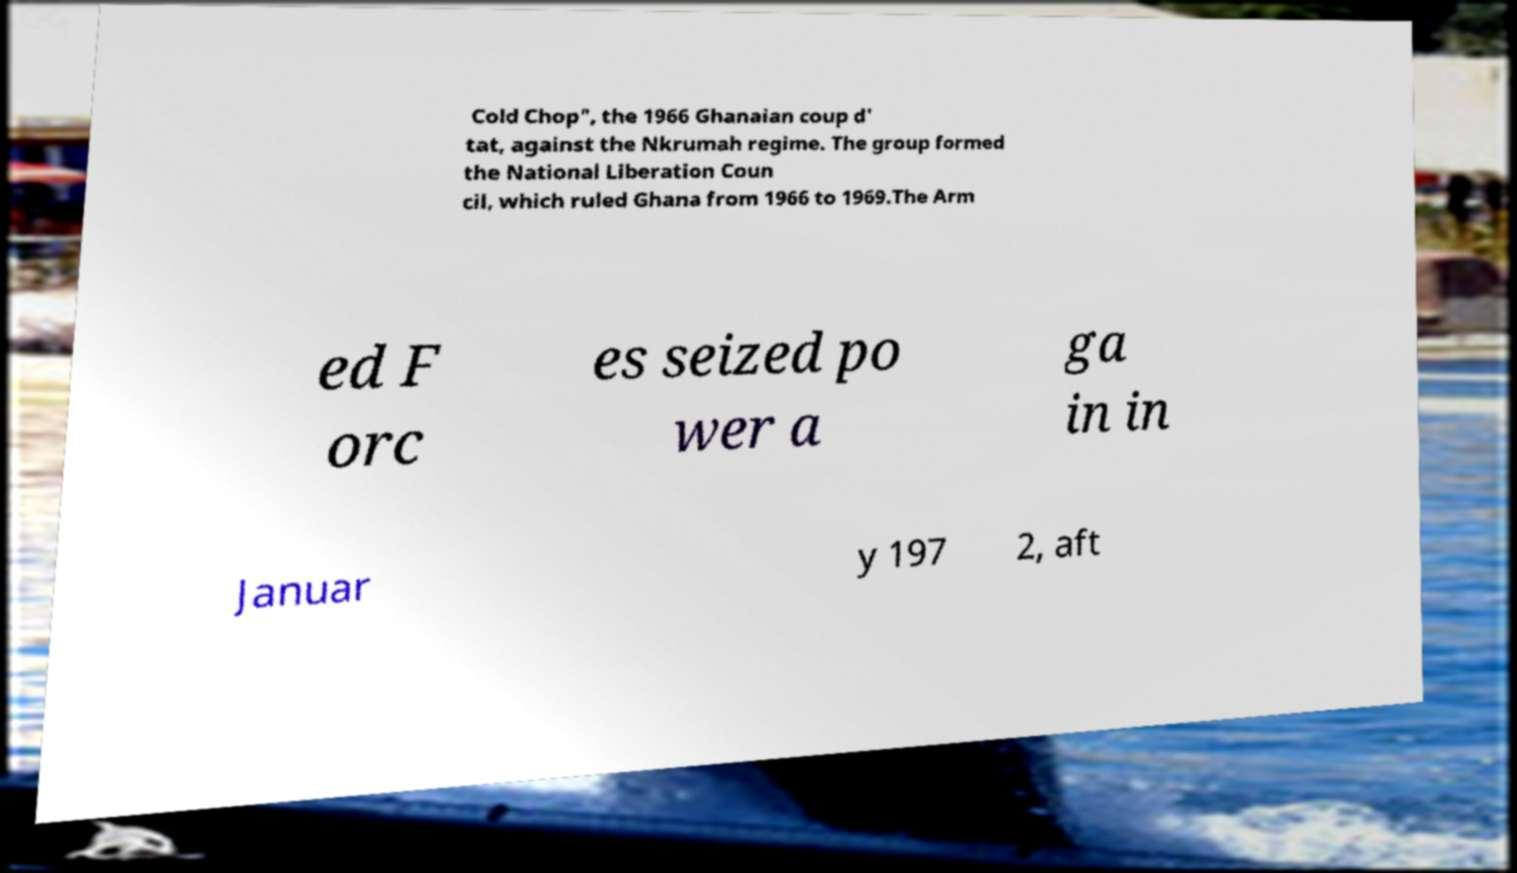I need the written content from this picture converted into text. Can you do that? Cold Chop", the 1966 Ghanaian coup d' tat, against the Nkrumah regime. The group formed the National Liberation Coun cil, which ruled Ghana from 1966 to 1969.The Arm ed F orc es seized po wer a ga in in Januar y 197 2, aft 